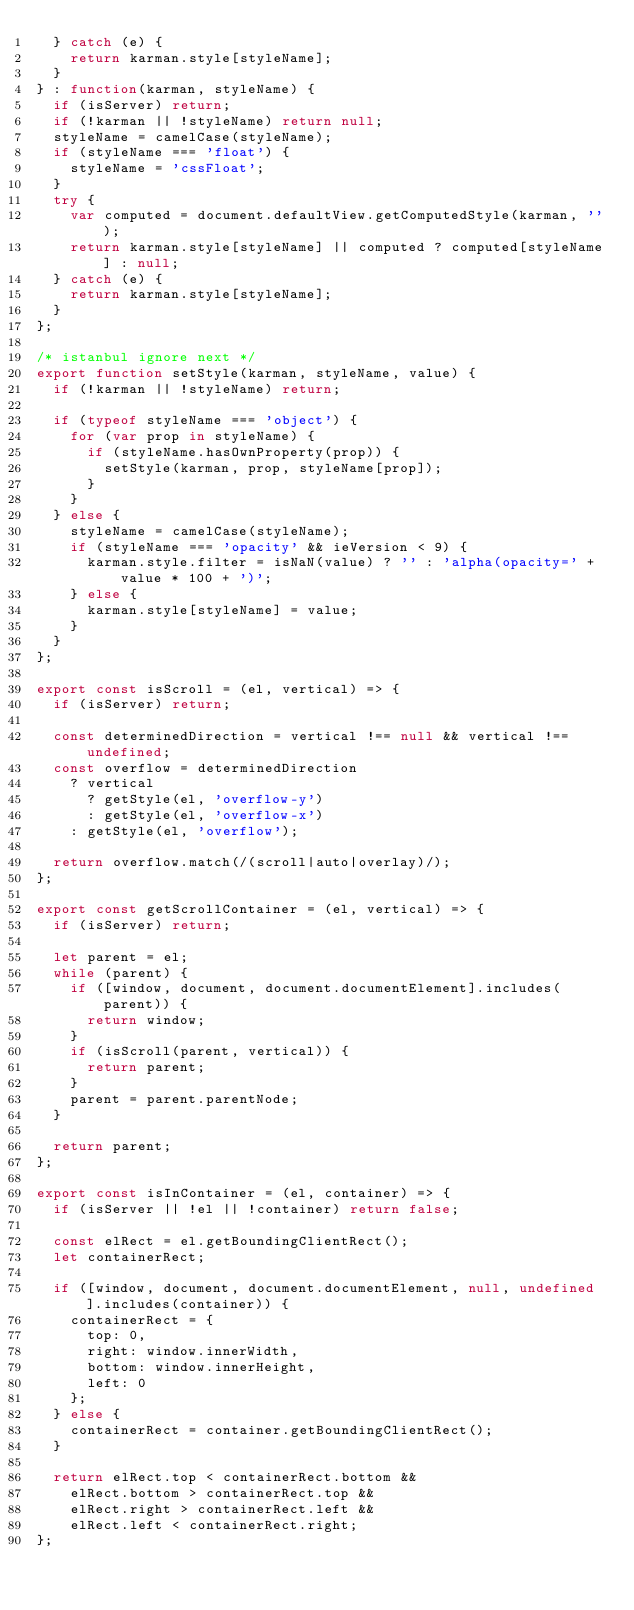<code> <loc_0><loc_0><loc_500><loc_500><_JavaScript_>  } catch (e) {
    return karman.style[styleName];
  }
} : function(karman, styleName) {
  if (isServer) return;
  if (!karman || !styleName) return null;
  styleName = camelCase(styleName);
  if (styleName === 'float') {
    styleName = 'cssFloat';
  }
  try {
    var computed = document.defaultView.getComputedStyle(karman, '');
    return karman.style[styleName] || computed ? computed[styleName] : null;
  } catch (e) {
    return karman.style[styleName];
  }
};

/* istanbul ignore next */
export function setStyle(karman, styleName, value) {
  if (!karman || !styleName) return;

  if (typeof styleName === 'object') {
    for (var prop in styleName) {
      if (styleName.hasOwnProperty(prop)) {
        setStyle(karman, prop, styleName[prop]);
      }
    }
  } else {
    styleName = camelCase(styleName);
    if (styleName === 'opacity' && ieVersion < 9) {
      karman.style.filter = isNaN(value) ? '' : 'alpha(opacity=' + value * 100 + ')';
    } else {
      karman.style[styleName] = value;
    }
  }
};

export const isScroll = (el, vertical) => {
  if (isServer) return;

  const determinedDirection = vertical !== null && vertical !== undefined;
  const overflow = determinedDirection
    ? vertical
      ? getStyle(el, 'overflow-y')
      : getStyle(el, 'overflow-x')
    : getStyle(el, 'overflow');

  return overflow.match(/(scroll|auto|overlay)/);
};

export const getScrollContainer = (el, vertical) => {
  if (isServer) return;

  let parent = el;
  while (parent) {
    if ([window, document, document.documentElement].includes(parent)) {
      return window;
    }
    if (isScroll(parent, vertical)) {
      return parent;
    }
    parent = parent.parentNode;
  }

  return parent;
};

export const isInContainer = (el, container) => {
  if (isServer || !el || !container) return false;

  const elRect = el.getBoundingClientRect();
  let containerRect;

  if ([window, document, document.documentElement, null, undefined].includes(container)) {
    containerRect = {
      top: 0,
      right: window.innerWidth,
      bottom: window.innerHeight,
      left: 0
    };
  } else {
    containerRect = container.getBoundingClientRect();
  }

  return elRect.top < containerRect.bottom &&
    elRect.bottom > containerRect.top &&
    elRect.right > containerRect.left &&
    elRect.left < containerRect.right;
};
</code> 